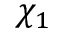Convert formula to latex. <formula><loc_0><loc_0><loc_500><loc_500>\chi _ { 1 }</formula> 